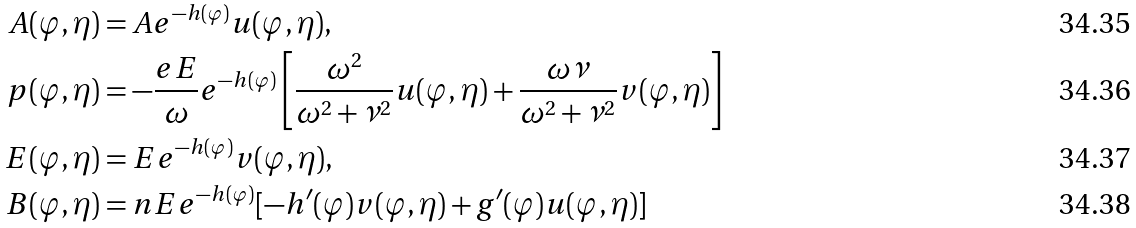Convert formula to latex. <formula><loc_0><loc_0><loc_500><loc_500>A ( \varphi , \eta ) & = A e ^ { - h ( \varphi ) } u ( \varphi , \eta ) , \\ p ( \varphi , \eta ) & = - \frac { e E } { \omega } e ^ { - h ( \varphi ) } \left [ \frac { \omega ^ { 2 } } { \omega ^ { 2 } + \nu ^ { 2 } } u ( \varphi , \eta ) + \frac { \omega \nu } { \omega ^ { 2 } + \nu ^ { 2 } } v ( \varphi , \eta ) \right ] \\ E ( \varphi , \eta ) & = E e ^ { - h ( \varphi ) } v ( \varphi , \eta ) , \\ B ( \varphi , \eta ) & = n E e ^ { - h ( \varphi ) } [ - h ^ { \prime } ( \varphi ) v ( \varphi , \eta ) + g ^ { \prime } ( \varphi ) u ( \varphi , \eta ) ]</formula> 